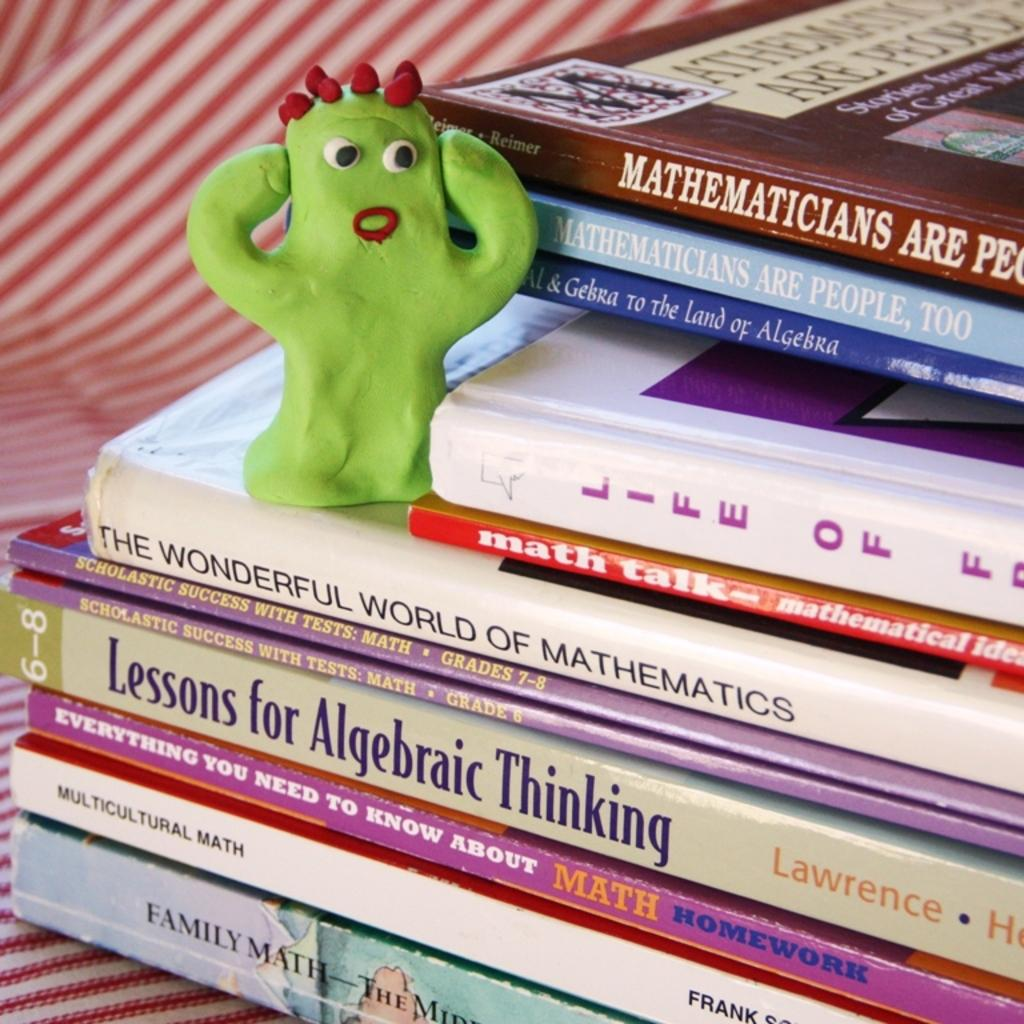What can be seen in the image? There is a collection of books in the image. Is there anything else present on the books? Yes, there is a toy on one of the books. What type of dinosaur ticket is visible on the books in the image? There is no dinosaur ticket present in the image; it only features a collection of books and a toy on one of the books. 